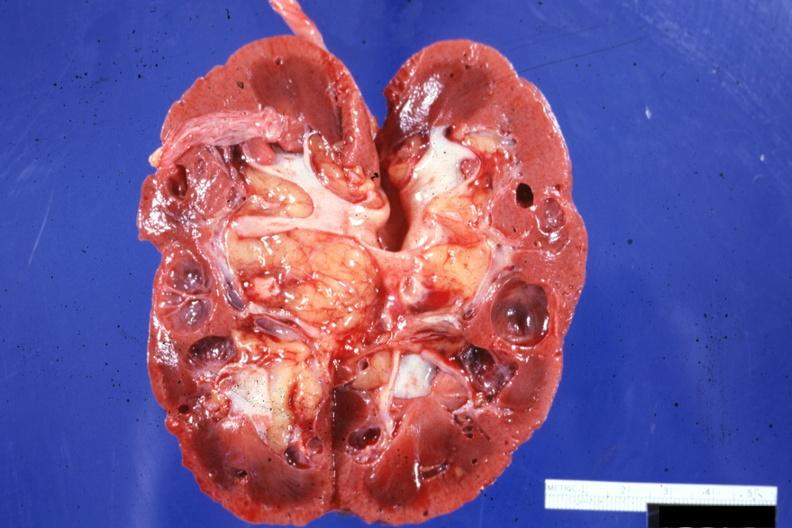what does this image show?
Answer the question using a single word or phrase. Cut surface 